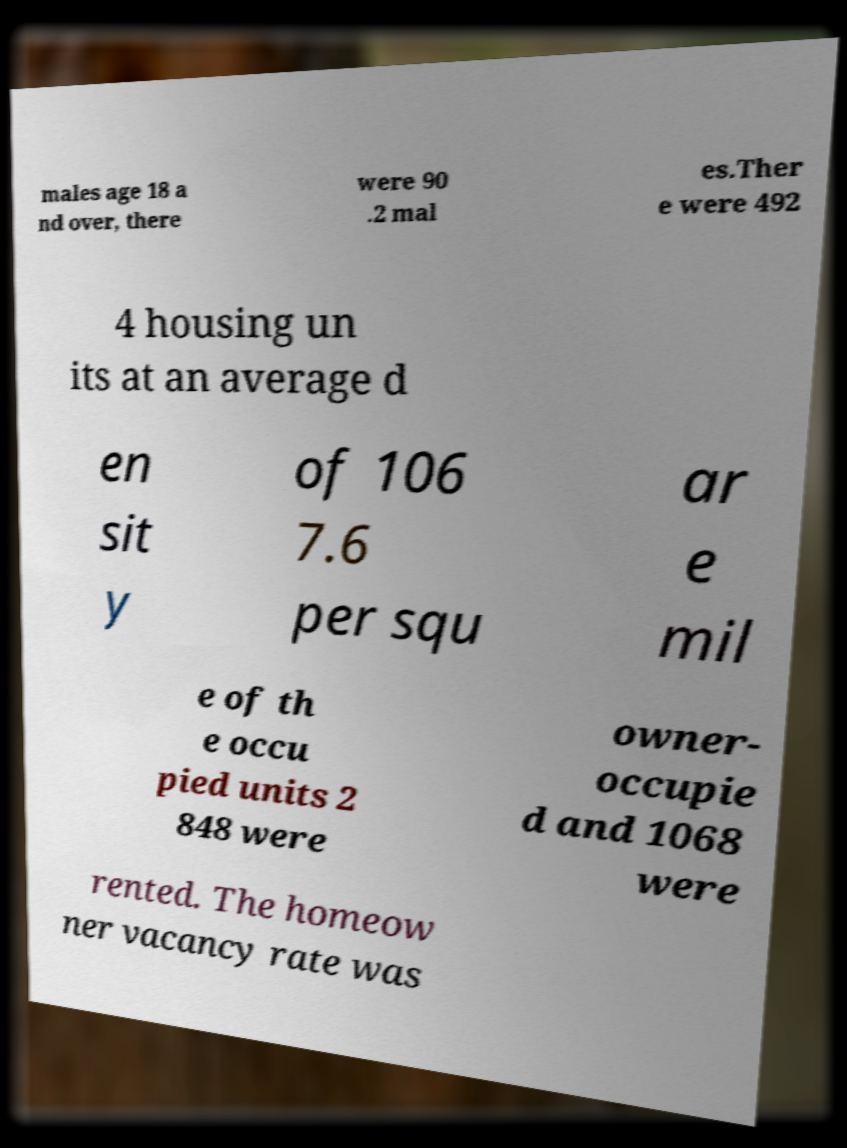Can you accurately transcribe the text from the provided image for me? males age 18 a nd over, there were 90 .2 mal es.Ther e were 492 4 housing un its at an average d en sit y of 106 7.6 per squ ar e mil e of th e occu pied units 2 848 were owner- occupie d and 1068 were rented. The homeow ner vacancy rate was 